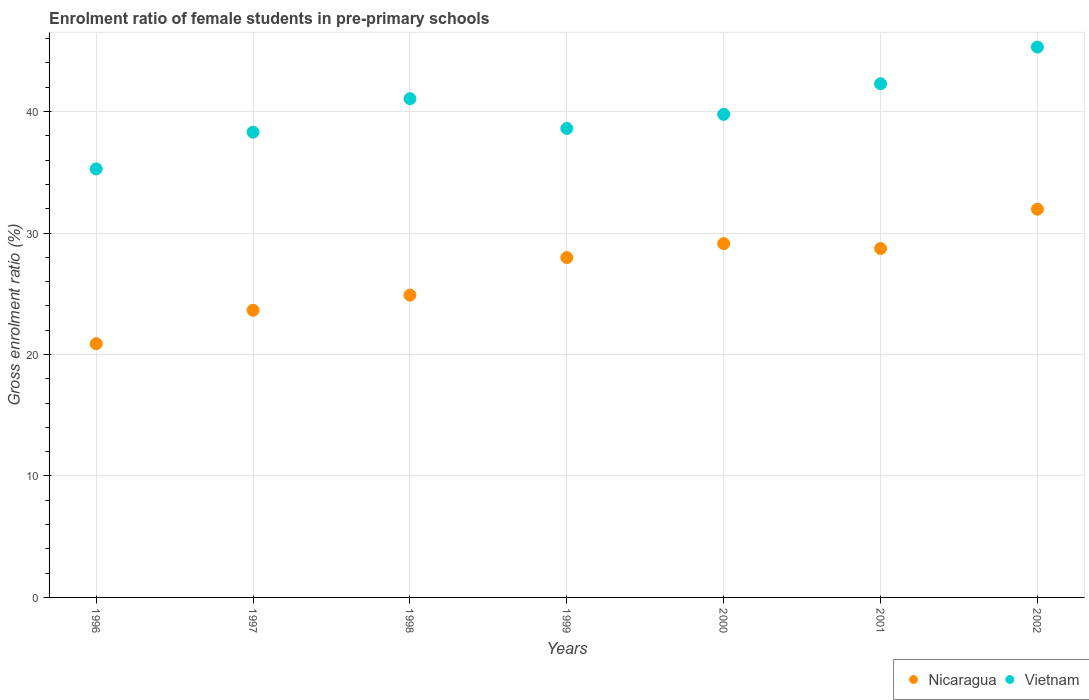Is the number of dotlines equal to the number of legend labels?
Offer a terse response. Yes. What is the enrolment ratio of female students in pre-primary schools in Vietnam in 1997?
Offer a very short reply. 38.3. Across all years, what is the maximum enrolment ratio of female students in pre-primary schools in Nicaragua?
Your response must be concise. 31.96. Across all years, what is the minimum enrolment ratio of female students in pre-primary schools in Vietnam?
Make the answer very short. 35.28. What is the total enrolment ratio of female students in pre-primary schools in Vietnam in the graph?
Keep it short and to the point. 280.62. What is the difference between the enrolment ratio of female students in pre-primary schools in Vietnam in 1999 and that in 2002?
Offer a terse response. -6.7. What is the difference between the enrolment ratio of female students in pre-primary schools in Vietnam in 1998 and the enrolment ratio of female students in pre-primary schools in Nicaragua in 1996?
Your response must be concise. 20.17. What is the average enrolment ratio of female students in pre-primary schools in Nicaragua per year?
Ensure brevity in your answer.  26.74. In the year 1996, what is the difference between the enrolment ratio of female students in pre-primary schools in Vietnam and enrolment ratio of female students in pre-primary schools in Nicaragua?
Your response must be concise. 14.39. What is the ratio of the enrolment ratio of female students in pre-primary schools in Vietnam in 1997 to that in 2000?
Keep it short and to the point. 0.96. Is the enrolment ratio of female students in pre-primary schools in Vietnam in 1996 less than that in 1997?
Your response must be concise. Yes. What is the difference between the highest and the second highest enrolment ratio of female students in pre-primary schools in Nicaragua?
Keep it short and to the point. 2.83. What is the difference between the highest and the lowest enrolment ratio of female students in pre-primary schools in Nicaragua?
Give a very brief answer. 11.07. In how many years, is the enrolment ratio of female students in pre-primary schools in Vietnam greater than the average enrolment ratio of female students in pre-primary schools in Vietnam taken over all years?
Keep it short and to the point. 3. Does the enrolment ratio of female students in pre-primary schools in Vietnam monotonically increase over the years?
Give a very brief answer. No. How many dotlines are there?
Your answer should be compact. 2. What is the difference between two consecutive major ticks on the Y-axis?
Make the answer very short. 10. Are the values on the major ticks of Y-axis written in scientific E-notation?
Provide a succinct answer. No. Does the graph contain any zero values?
Offer a terse response. No. Where does the legend appear in the graph?
Keep it short and to the point. Bottom right. How are the legend labels stacked?
Provide a succinct answer. Horizontal. What is the title of the graph?
Keep it short and to the point. Enrolment ratio of female students in pre-primary schools. Does "Eritrea" appear as one of the legend labels in the graph?
Offer a very short reply. No. What is the label or title of the X-axis?
Your answer should be compact. Years. What is the label or title of the Y-axis?
Offer a terse response. Gross enrolment ratio (%). What is the Gross enrolment ratio (%) of Nicaragua in 1996?
Your answer should be very brief. 20.89. What is the Gross enrolment ratio (%) of Vietnam in 1996?
Keep it short and to the point. 35.28. What is the Gross enrolment ratio (%) in Nicaragua in 1997?
Provide a short and direct response. 23.64. What is the Gross enrolment ratio (%) of Vietnam in 1997?
Provide a succinct answer. 38.3. What is the Gross enrolment ratio (%) in Nicaragua in 1998?
Offer a terse response. 24.89. What is the Gross enrolment ratio (%) of Vietnam in 1998?
Your answer should be very brief. 41.06. What is the Gross enrolment ratio (%) in Nicaragua in 1999?
Give a very brief answer. 27.98. What is the Gross enrolment ratio (%) in Vietnam in 1999?
Make the answer very short. 38.61. What is the Gross enrolment ratio (%) in Nicaragua in 2000?
Provide a short and direct response. 29.13. What is the Gross enrolment ratio (%) in Vietnam in 2000?
Provide a short and direct response. 39.77. What is the Gross enrolment ratio (%) of Nicaragua in 2001?
Offer a terse response. 28.72. What is the Gross enrolment ratio (%) of Vietnam in 2001?
Offer a terse response. 42.29. What is the Gross enrolment ratio (%) of Nicaragua in 2002?
Make the answer very short. 31.96. What is the Gross enrolment ratio (%) of Vietnam in 2002?
Make the answer very short. 45.31. Across all years, what is the maximum Gross enrolment ratio (%) of Nicaragua?
Keep it short and to the point. 31.96. Across all years, what is the maximum Gross enrolment ratio (%) of Vietnam?
Give a very brief answer. 45.31. Across all years, what is the minimum Gross enrolment ratio (%) in Nicaragua?
Give a very brief answer. 20.89. Across all years, what is the minimum Gross enrolment ratio (%) in Vietnam?
Offer a very short reply. 35.28. What is the total Gross enrolment ratio (%) in Nicaragua in the graph?
Keep it short and to the point. 187.21. What is the total Gross enrolment ratio (%) of Vietnam in the graph?
Offer a terse response. 280.62. What is the difference between the Gross enrolment ratio (%) of Nicaragua in 1996 and that in 1997?
Offer a terse response. -2.75. What is the difference between the Gross enrolment ratio (%) in Vietnam in 1996 and that in 1997?
Your answer should be very brief. -3.03. What is the difference between the Gross enrolment ratio (%) in Nicaragua in 1996 and that in 1998?
Offer a terse response. -4. What is the difference between the Gross enrolment ratio (%) in Vietnam in 1996 and that in 1998?
Ensure brevity in your answer.  -5.78. What is the difference between the Gross enrolment ratio (%) of Nicaragua in 1996 and that in 1999?
Give a very brief answer. -7.09. What is the difference between the Gross enrolment ratio (%) of Vietnam in 1996 and that in 1999?
Ensure brevity in your answer.  -3.33. What is the difference between the Gross enrolment ratio (%) of Nicaragua in 1996 and that in 2000?
Your response must be concise. -8.24. What is the difference between the Gross enrolment ratio (%) of Vietnam in 1996 and that in 2000?
Your response must be concise. -4.49. What is the difference between the Gross enrolment ratio (%) of Nicaragua in 1996 and that in 2001?
Your answer should be compact. -7.83. What is the difference between the Gross enrolment ratio (%) of Vietnam in 1996 and that in 2001?
Make the answer very short. -7.01. What is the difference between the Gross enrolment ratio (%) in Nicaragua in 1996 and that in 2002?
Offer a terse response. -11.07. What is the difference between the Gross enrolment ratio (%) in Vietnam in 1996 and that in 2002?
Keep it short and to the point. -10.03. What is the difference between the Gross enrolment ratio (%) in Nicaragua in 1997 and that in 1998?
Your answer should be very brief. -1.24. What is the difference between the Gross enrolment ratio (%) in Vietnam in 1997 and that in 1998?
Give a very brief answer. -2.76. What is the difference between the Gross enrolment ratio (%) of Nicaragua in 1997 and that in 1999?
Keep it short and to the point. -4.34. What is the difference between the Gross enrolment ratio (%) in Vietnam in 1997 and that in 1999?
Give a very brief answer. -0.31. What is the difference between the Gross enrolment ratio (%) in Nicaragua in 1997 and that in 2000?
Keep it short and to the point. -5.48. What is the difference between the Gross enrolment ratio (%) in Vietnam in 1997 and that in 2000?
Your response must be concise. -1.47. What is the difference between the Gross enrolment ratio (%) in Nicaragua in 1997 and that in 2001?
Keep it short and to the point. -5.08. What is the difference between the Gross enrolment ratio (%) of Vietnam in 1997 and that in 2001?
Provide a succinct answer. -3.98. What is the difference between the Gross enrolment ratio (%) in Nicaragua in 1997 and that in 2002?
Keep it short and to the point. -8.32. What is the difference between the Gross enrolment ratio (%) of Vietnam in 1997 and that in 2002?
Make the answer very short. -7.01. What is the difference between the Gross enrolment ratio (%) in Nicaragua in 1998 and that in 1999?
Offer a very short reply. -3.09. What is the difference between the Gross enrolment ratio (%) of Vietnam in 1998 and that in 1999?
Your answer should be very brief. 2.45. What is the difference between the Gross enrolment ratio (%) in Nicaragua in 1998 and that in 2000?
Give a very brief answer. -4.24. What is the difference between the Gross enrolment ratio (%) in Vietnam in 1998 and that in 2000?
Offer a very short reply. 1.29. What is the difference between the Gross enrolment ratio (%) of Nicaragua in 1998 and that in 2001?
Your response must be concise. -3.83. What is the difference between the Gross enrolment ratio (%) of Vietnam in 1998 and that in 2001?
Provide a succinct answer. -1.23. What is the difference between the Gross enrolment ratio (%) of Nicaragua in 1998 and that in 2002?
Provide a short and direct response. -7.08. What is the difference between the Gross enrolment ratio (%) in Vietnam in 1998 and that in 2002?
Give a very brief answer. -4.25. What is the difference between the Gross enrolment ratio (%) in Nicaragua in 1999 and that in 2000?
Give a very brief answer. -1.15. What is the difference between the Gross enrolment ratio (%) in Vietnam in 1999 and that in 2000?
Keep it short and to the point. -1.16. What is the difference between the Gross enrolment ratio (%) in Nicaragua in 1999 and that in 2001?
Make the answer very short. -0.74. What is the difference between the Gross enrolment ratio (%) in Vietnam in 1999 and that in 2001?
Provide a succinct answer. -3.68. What is the difference between the Gross enrolment ratio (%) of Nicaragua in 1999 and that in 2002?
Provide a succinct answer. -3.98. What is the difference between the Gross enrolment ratio (%) in Vietnam in 1999 and that in 2002?
Make the answer very short. -6.7. What is the difference between the Gross enrolment ratio (%) in Nicaragua in 2000 and that in 2001?
Your response must be concise. 0.41. What is the difference between the Gross enrolment ratio (%) of Vietnam in 2000 and that in 2001?
Give a very brief answer. -2.52. What is the difference between the Gross enrolment ratio (%) in Nicaragua in 2000 and that in 2002?
Your response must be concise. -2.83. What is the difference between the Gross enrolment ratio (%) in Vietnam in 2000 and that in 2002?
Make the answer very short. -5.54. What is the difference between the Gross enrolment ratio (%) of Nicaragua in 2001 and that in 2002?
Provide a short and direct response. -3.24. What is the difference between the Gross enrolment ratio (%) of Vietnam in 2001 and that in 2002?
Ensure brevity in your answer.  -3.02. What is the difference between the Gross enrolment ratio (%) in Nicaragua in 1996 and the Gross enrolment ratio (%) in Vietnam in 1997?
Your answer should be compact. -17.41. What is the difference between the Gross enrolment ratio (%) of Nicaragua in 1996 and the Gross enrolment ratio (%) of Vietnam in 1998?
Provide a succinct answer. -20.17. What is the difference between the Gross enrolment ratio (%) of Nicaragua in 1996 and the Gross enrolment ratio (%) of Vietnam in 1999?
Offer a very short reply. -17.72. What is the difference between the Gross enrolment ratio (%) of Nicaragua in 1996 and the Gross enrolment ratio (%) of Vietnam in 2000?
Make the answer very short. -18.88. What is the difference between the Gross enrolment ratio (%) in Nicaragua in 1996 and the Gross enrolment ratio (%) in Vietnam in 2001?
Provide a short and direct response. -21.4. What is the difference between the Gross enrolment ratio (%) in Nicaragua in 1996 and the Gross enrolment ratio (%) in Vietnam in 2002?
Offer a terse response. -24.42. What is the difference between the Gross enrolment ratio (%) in Nicaragua in 1997 and the Gross enrolment ratio (%) in Vietnam in 1998?
Provide a short and direct response. -17.42. What is the difference between the Gross enrolment ratio (%) of Nicaragua in 1997 and the Gross enrolment ratio (%) of Vietnam in 1999?
Ensure brevity in your answer.  -14.97. What is the difference between the Gross enrolment ratio (%) of Nicaragua in 1997 and the Gross enrolment ratio (%) of Vietnam in 2000?
Your response must be concise. -16.13. What is the difference between the Gross enrolment ratio (%) of Nicaragua in 1997 and the Gross enrolment ratio (%) of Vietnam in 2001?
Make the answer very short. -18.65. What is the difference between the Gross enrolment ratio (%) in Nicaragua in 1997 and the Gross enrolment ratio (%) in Vietnam in 2002?
Provide a short and direct response. -21.67. What is the difference between the Gross enrolment ratio (%) of Nicaragua in 1998 and the Gross enrolment ratio (%) of Vietnam in 1999?
Ensure brevity in your answer.  -13.72. What is the difference between the Gross enrolment ratio (%) of Nicaragua in 1998 and the Gross enrolment ratio (%) of Vietnam in 2000?
Your response must be concise. -14.88. What is the difference between the Gross enrolment ratio (%) of Nicaragua in 1998 and the Gross enrolment ratio (%) of Vietnam in 2001?
Offer a terse response. -17.4. What is the difference between the Gross enrolment ratio (%) in Nicaragua in 1998 and the Gross enrolment ratio (%) in Vietnam in 2002?
Offer a terse response. -20.42. What is the difference between the Gross enrolment ratio (%) of Nicaragua in 1999 and the Gross enrolment ratio (%) of Vietnam in 2000?
Your response must be concise. -11.79. What is the difference between the Gross enrolment ratio (%) of Nicaragua in 1999 and the Gross enrolment ratio (%) of Vietnam in 2001?
Provide a succinct answer. -14.31. What is the difference between the Gross enrolment ratio (%) in Nicaragua in 1999 and the Gross enrolment ratio (%) in Vietnam in 2002?
Your answer should be compact. -17.33. What is the difference between the Gross enrolment ratio (%) in Nicaragua in 2000 and the Gross enrolment ratio (%) in Vietnam in 2001?
Your answer should be compact. -13.16. What is the difference between the Gross enrolment ratio (%) of Nicaragua in 2000 and the Gross enrolment ratio (%) of Vietnam in 2002?
Ensure brevity in your answer.  -16.18. What is the difference between the Gross enrolment ratio (%) in Nicaragua in 2001 and the Gross enrolment ratio (%) in Vietnam in 2002?
Offer a very short reply. -16.59. What is the average Gross enrolment ratio (%) in Nicaragua per year?
Give a very brief answer. 26.74. What is the average Gross enrolment ratio (%) of Vietnam per year?
Keep it short and to the point. 40.09. In the year 1996, what is the difference between the Gross enrolment ratio (%) of Nicaragua and Gross enrolment ratio (%) of Vietnam?
Your response must be concise. -14.39. In the year 1997, what is the difference between the Gross enrolment ratio (%) in Nicaragua and Gross enrolment ratio (%) in Vietnam?
Provide a short and direct response. -14.66. In the year 1998, what is the difference between the Gross enrolment ratio (%) of Nicaragua and Gross enrolment ratio (%) of Vietnam?
Provide a short and direct response. -16.17. In the year 1999, what is the difference between the Gross enrolment ratio (%) of Nicaragua and Gross enrolment ratio (%) of Vietnam?
Your answer should be very brief. -10.63. In the year 2000, what is the difference between the Gross enrolment ratio (%) of Nicaragua and Gross enrolment ratio (%) of Vietnam?
Offer a very short reply. -10.64. In the year 2001, what is the difference between the Gross enrolment ratio (%) in Nicaragua and Gross enrolment ratio (%) in Vietnam?
Provide a succinct answer. -13.57. In the year 2002, what is the difference between the Gross enrolment ratio (%) in Nicaragua and Gross enrolment ratio (%) in Vietnam?
Your answer should be very brief. -13.35. What is the ratio of the Gross enrolment ratio (%) in Nicaragua in 1996 to that in 1997?
Offer a terse response. 0.88. What is the ratio of the Gross enrolment ratio (%) of Vietnam in 1996 to that in 1997?
Provide a short and direct response. 0.92. What is the ratio of the Gross enrolment ratio (%) in Nicaragua in 1996 to that in 1998?
Your answer should be very brief. 0.84. What is the ratio of the Gross enrolment ratio (%) in Vietnam in 1996 to that in 1998?
Provide a short and direct response. 0.86. What is the ratio of the Gross enrolment ratio (%) of Nicaragua in 1996 to that in 1999?
Your answer should be very brief. 0.75. What is the ratio of the Gross enrolment ratio (%) of Vietnam in 1996 to that in 1999?
Ensure brevity in your answer.  0.91. What is the ratio of the Gross enrolment ratio (%) of Nicaragua in 1996 to that in 2000?
Make the answer very short. 0.72. What is the ratio of the Gross enrolment ratio (%) in Vietnam in 1996 to that in 2000?
Offer a very short reply. 0.89. What is the ratio of the Gross enrolment ratio (%) of Nicaragua in 1996 to that in 2001?
Provide a succinct answer. 0.73. What is the ratio of the Gross enrolment ratio (%) of Vietnam in 1996 to that in 2001?
Ensure brevity in your answer.  0.83. What is the ratio of the Gross enrolment ratio (%) of Nicaragua in 1996 to that in 2002?
Make the answer very short. 0.65. What is the ratio of the Gross enrolment ratio (%) in Vietnam in 1996 to that in 2002?
Provide a short and direct response. 0.78. What is the ratio of the Gross enrolment ratio (%) of Vietnam in 1997 to that in 1998?
Your answer should be very brief. 0.93. What is the ratio of the Gross enrolment ratio (%) of Nicaragua in 1997 to that in 1999?
Give a very brief answer. 0.84. What is the ratio of the Gross enrolment ratio (%) in Nicaragua in 1997 to that in 2000?
Your response must be concise. 0.81. What is the ratio of the Gross enrolment ratio (%) of Vietnam in 1997 to that in 2000?
Provide a short and direct response. 0.96. What is the ratio of the Gross enrolment ratio (%) in Nicaragua in 1997 to that in 2001?
Provide a short and direct response. 0.82. What is the ratio of the Gross enrolment ratio (%) in Vietnam in 1997 to that in 2001?
Keep it short and to the point. 0.91. What is the ratio of the Gross enrolment ratio (%) in Nicaragua in 1997 to that in 2002?
Offer a very short reply. 0.74. What is the ratio of the Gross enrolment ratio (%) of Vietnam in 1997 to that in 2002?
Offer a terse response. 0.85. What is the ratio of the Gross enrolment ratio (%) of Nicaragua in 1998 to that in 1999?
Your answer should be compact. 0.89. What is the ratio of the Gross enrolment ratio (%) of Vietnam in 1998 to that in 1999?
Your answer should be very brief. 1.06. What is the ratio of the Gross enrolment ratio (%) of Nicaragua in 1998 to that in 2000?
Your response must be concise. 0.85. What is the ratio of the Gross enrolment ratio (%) of Vietnam in 1998 to that in 2000?
Give a very brief answer. 1.03. What is the ratio of the Gross enrolment ratio (%) of Nicaragua in 1998 to that in 2001?
Your answer should be very brief. 0.87. What is the ratio of the Gross enrolment ratio (%) of Vietnam in 1998 to that in 2001?
Your response must be concise. 0.97. What is the ratio of the Gross enrolment ratio (%) of Nicaragua in 1998 to that in 2002?
Offer a very short reply. 0.78. What is the ratio of the Gross enrolment ratio (%) of Vietnam in 1998 to that in 2002?
Make the answer very short. 0.91. What is the ratio of the Gross enrolment ratio (%) of Nicaragua in 1999 to that in 2000?
Give a very brief answer. 0.96. What is the ratio of the Gross enrolment ratio (%) in Vietnam in 1999 to that in 2000?
Your answer should be compact. 0.97. What is the ratio of the Gross enrolment ratio (%) in Nicaragua in 1999 to that in 2001?
Provide a short and direct response. 0.97. What is the ratio of the Gross enrolment ratio (%) of Nicaragua in 1999 to that in 2002?
Give a very brief answer. 0.88. What is the ratio of the Gross enrolment ratio (%) of Vietnam in 1999 to that in 2002?
Keep it short and to the point. 0.85. What is the ratio of the Gross enrolment ratio (%) of Nicaragua in 2000 to that in 2001?
Provide a succinct answer. 1.01. What is the ratio of the Gross enrolment ratio (%) in Vietnam in 2000 to that in 2001?
Keep it short and to the point. 0.94. What is the ratio of the Gross enrolment ratio (%) in Nicaragua in 2000 to that in 2002?
Ensure brevity in your answer.  0.91. What is the ratio of the Gross enrolment ratio (%) in Vietnam in 2000 to that in 2002?
Your answer should be compact. 0.88. What is the ratio of the Gross enrolment ratio (%) of Nicaragua in 2001 to that in 2002?
Ensure brevity in your answer.  0.9. What is the difference between the highest and the second highest Gross enrolment ratio (%) in Nicaragua?
Give a very brief answer. 2.83. What is the difference between the highest and the second highest Gross enrolment ratio (%) of Vietnam?
Your answer should be compact. 3.02. What is the difference between the highest and the lowest Gross enrolment ratio (%) in Nicaragua?
Make the answer very short. 11.07. What is the difference between the highest and the lowest Gross enrolment ratio (%) in Vietnam?
Offer a very short reply. 10.03. 